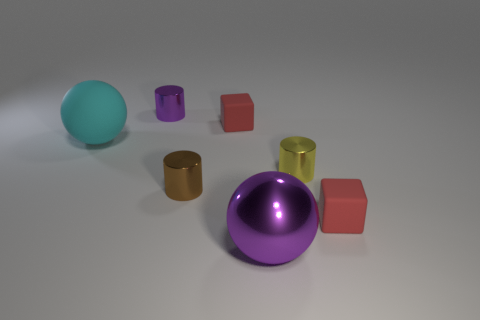Subtract all yellow cylinders. Subtract all green blocks. How many cylinders are left? 2 Add 3 large blue cylinders. How many objects exist? 10 Subtract all spheres. How many objects are left? 5 Add 2 small purple metal cylinders. How many small purple metal cylinders are left? 3 Add 5 big blue balls. How many big blue balls exist? 5 Subtract 0 purple blocks. How many objects are left? 7 Subtract all big gray rubber objects. Subtract all matte objects. How many objects are left? 4 